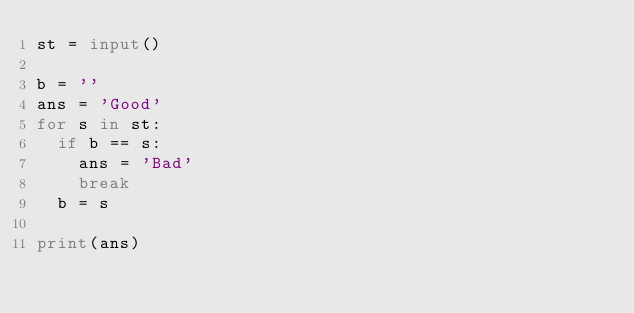Convert code to text. <code><loc_0><loc_0><loc_500><loc_500><_Python_>st = input()

b = ''
ans = 'Good'
for s in st:
  if b == s:
    ans = 'Bad'
    break
  b = s

print(ans)</code> 